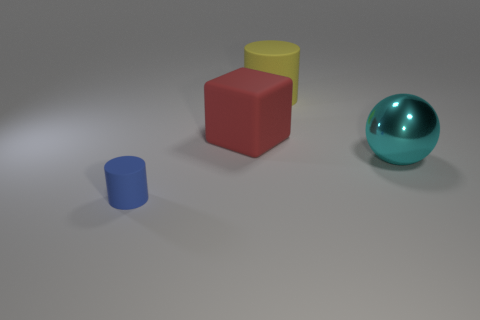What can you tell me about the lighting and shadows in the scene? The scene is illuminated from the top left, which is evident from the shadows cast diagonally towards the bottom right. The objects have distinct shadows that match their shapes, indicating a single light source, and the shadows are soft-edged, which suggests the light is diffused rather than direct. 